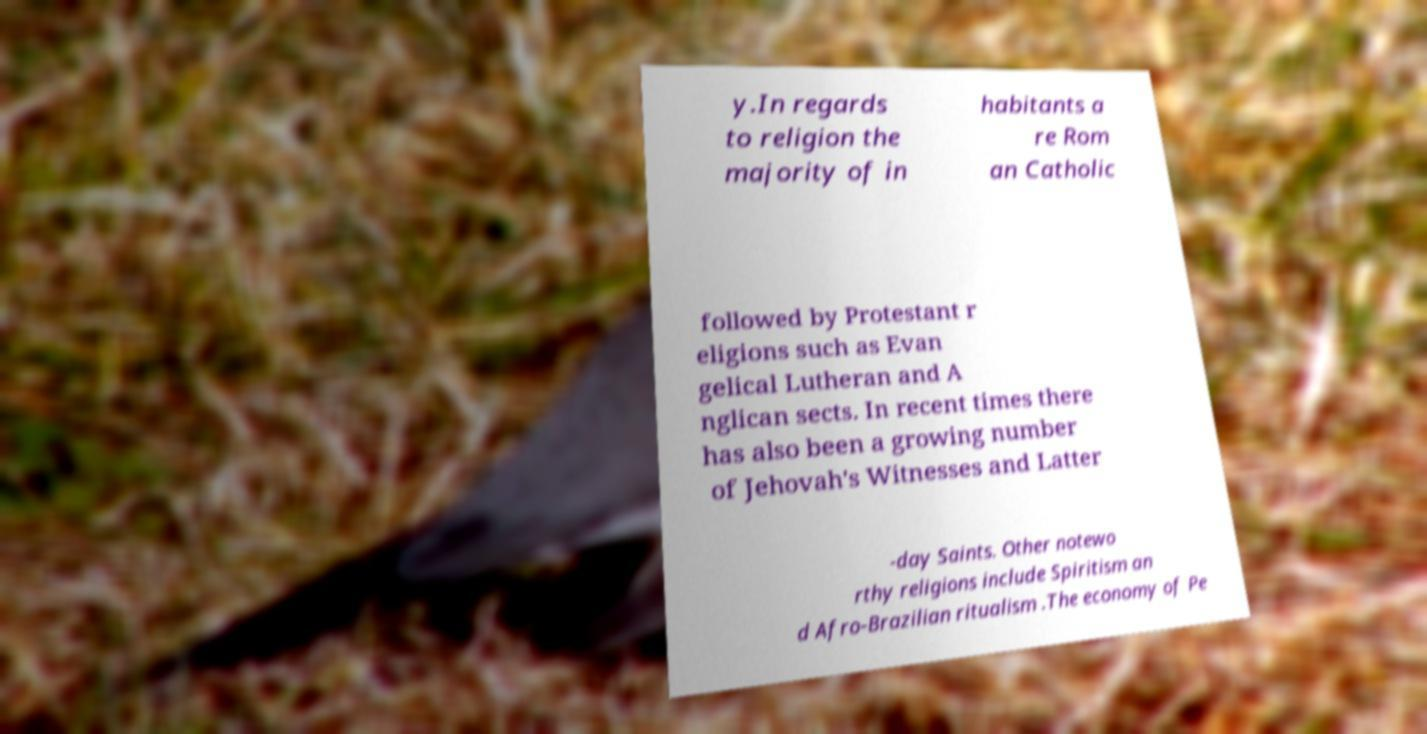For documentation purposes, I need the text within this image transcribed. Could you provide that? y.In regards to religion the majority of in habitants a re Rom an Catholic followed by Protestant r eligions such as Evan gelical Lutheran and A nglican sects. In recent times there has also been a growing number of Jehovah's Witnesses and Latter -day Saints. Other notewo rthy religions include Spiritism an d Afro-Brazilian ritualism .The economy of Pe 